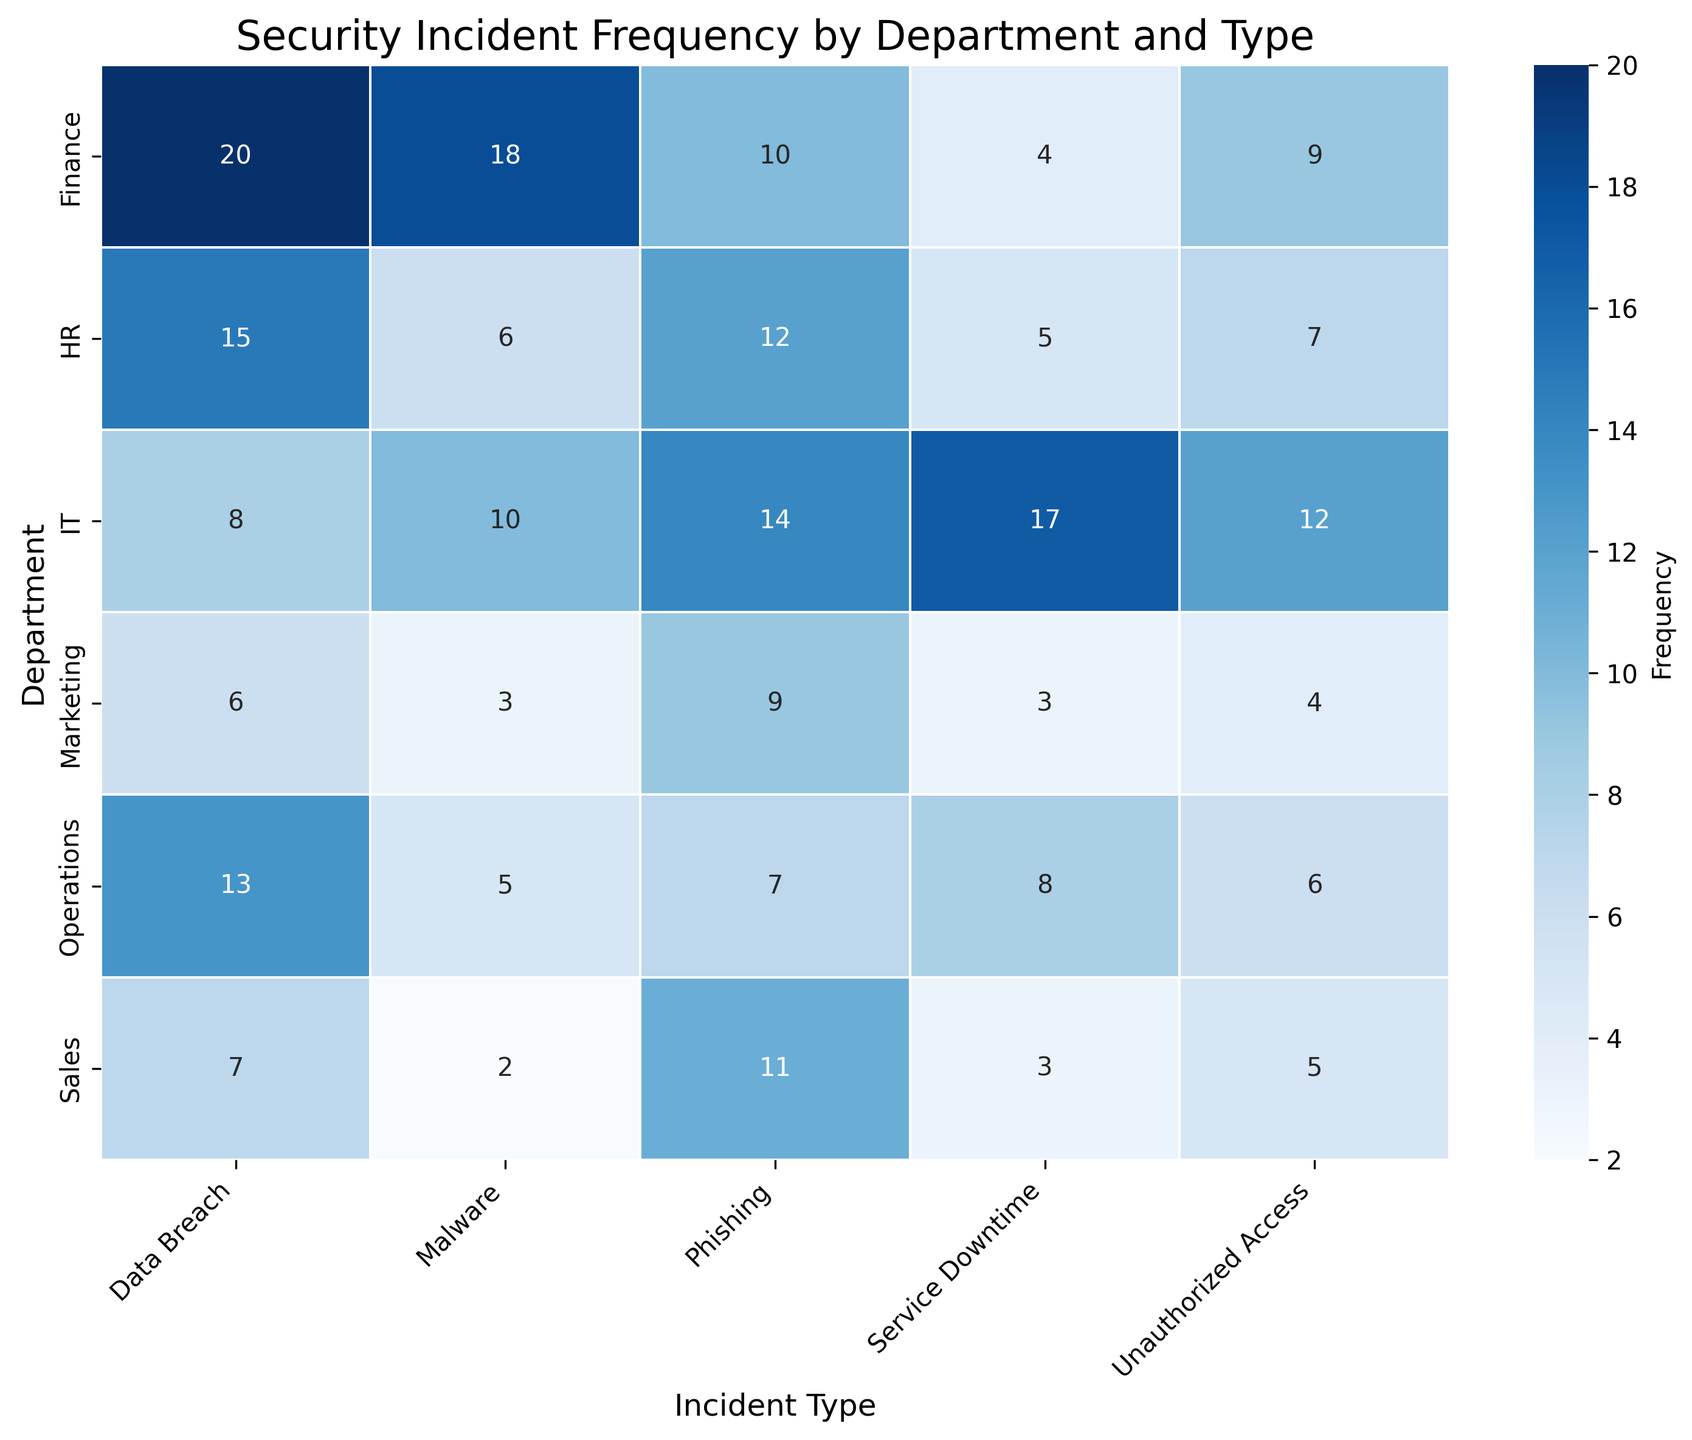Which department has the highest frequency of Data Breach incidents? Look at the column labeled "Data Breach" and find the cell with the highest value. The highest value is 20, which is for the Finance department.
Answer: Finance Which incident type has the highest frequency in the Finance department? Look at the row for the Finance department and find the cell with the highest value. The highest value is 20, which corresponds to "Data Breach".
Answer: Data Breach Compare the frequency of Phishing incidents between HR and IT departments? Look at the "Phishing" column and compare the values for HR and IT. HR has 12 while IT has 14.
Answer: IT has more Phishing incidents than HR What is the total number of incidents in the Sales department? Sum up all the values in the Sales department row: 7 (Data Breach) + 5 (Unauthorized Access) + 3 (Service Downtime) + 11 (Phishing) + 2 (Malware) = 28.
Answer: 28 Which department has the lowest frequency of Malware incidents? Look at the "Malware" column and find the smallest value. The smallest value is 2, which is for Sales.
Answer: Sales Are Phishing incidents more common in Marketing or HR? Compare the values in the "Phishing" column for Marketing and HR. Marketing has 9 while HR has 12.
Answer: HR What is the combined frequency of Unauthorized Access incidents in IT and Operations? Sum up the values for "Unauthorized Access" in IT and Operations. IT has 12 and Operations has 6. 12 + 6 = 18.
Answer: 18 Which department shows the highest frequency for Service Downtime incidents? Look at the column labeled "Service Downtime" and find the highest value. The highest value is 17, which is for IT.
Answer: IT What is the total frequency of Data Breach incidents across all departments? Sum up the values in the "Data Breach" column: 15 (HR) + 20 (Finance) + 8 (IT) + 7 (Sales) + 6 (Marketing) + 13 (Operations) = 69.
Answer: 69 Which incident type has a relatively uniform distribution across all departments? Compare the values across departments for each incident type to find the type with the most similar numbers. "Service Downtime" has relatively close frequencies: 5 (HR), 4 (Finance), 17 (IT), 3 (Sales), 3 (Marketing), 8 (Operations).
Answer: Service Downtime 